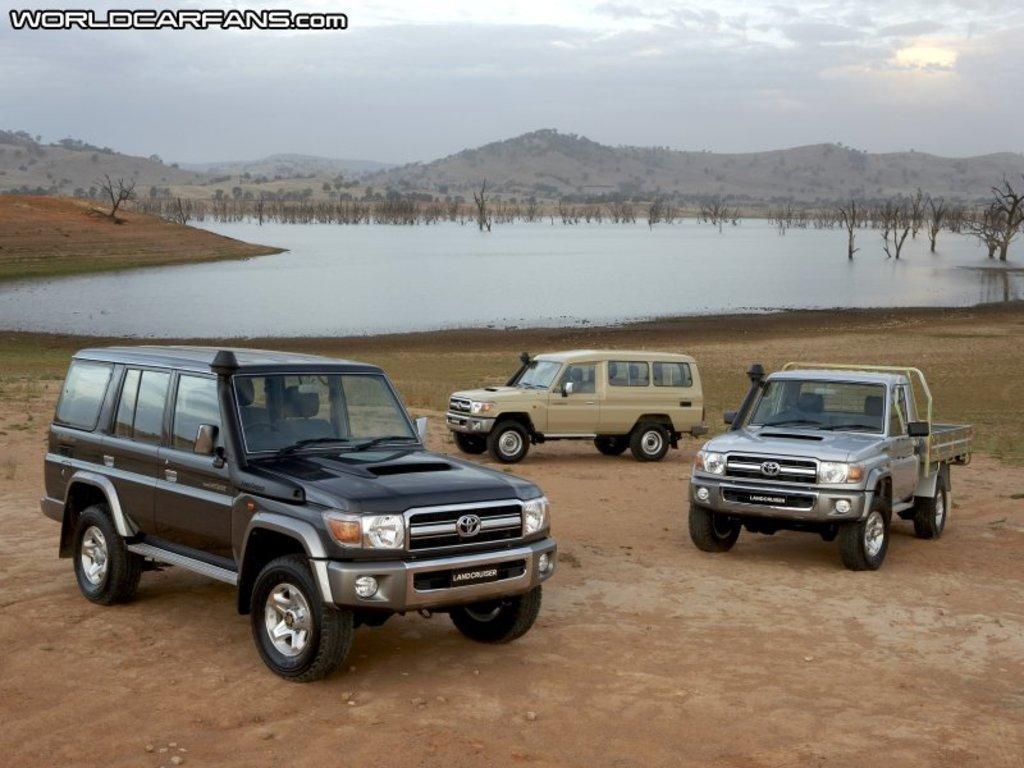How would you summarize this image in a sentence or two? In this image we can see three cars which are of different colors and two are of same model and the other is of different model and at the background of the image there is water, mountains, some trees and clear sky. 